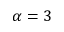<formula> <loc_0><loc_0><loc_500><loc_500>\alpha = 3</formula> 